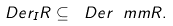<formula> <loc_0><loc_0><loc_500><loc_500>\ D e r _ { I } R \subseteq \ D e r _ { \ } m m R .</formula> 